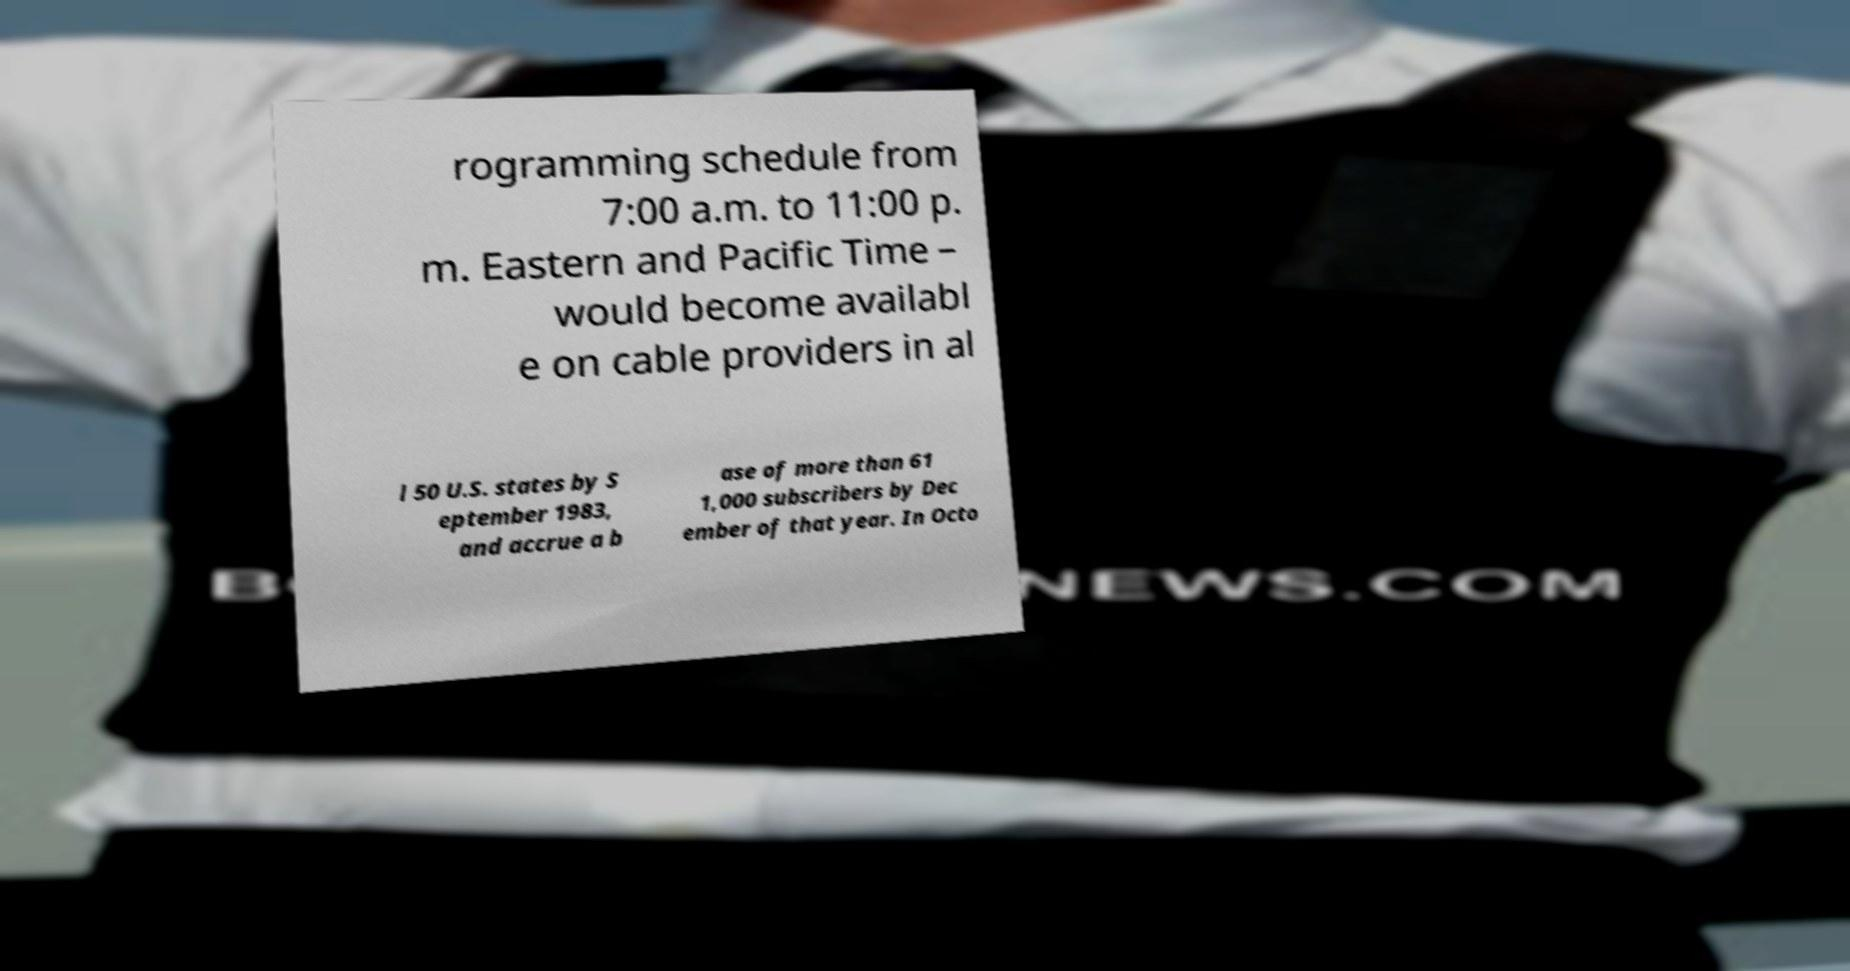Please read and relay the text visible in this image. What does it say? rogramming schedule from 7:00 a.m. to 11:00 p. m. Eastern and Pacific Time – would become availabl e on cable providers in al l 50 U.S. states by S eptember 1983, and accrue a b ase of more than 61 1,000 subscribers by Dec ember of that year. In Octo 